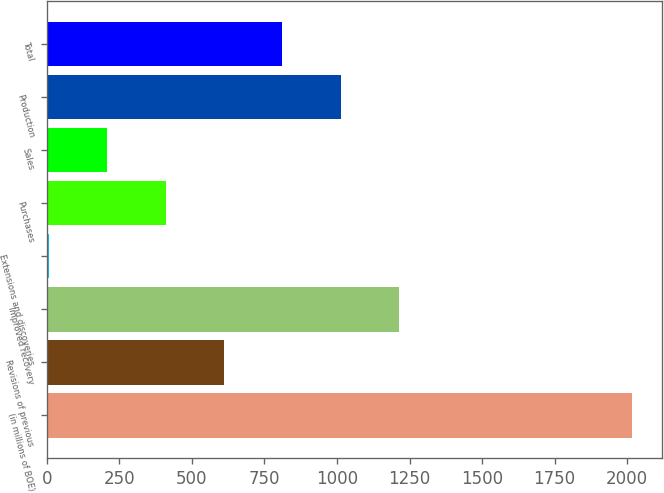Convert chart to OTSL. <chart><loc_0><loc_0><loc_500><loc_500><bar_chart><fcel>(in millions of BOE)<fcel>Revisions of previous<fcel>Improved recovery<fcel>Extensions and discoveries<fcel>Purchases<fcel>Sales<fcel>Production<fcel>Total<nl><fcel>2018<fcel>610.3<fcel>1213.6<fcel>7<fcel>409.2<fcel>208.1<fcel>1012.5<fcel>811.4<nl></chart> 